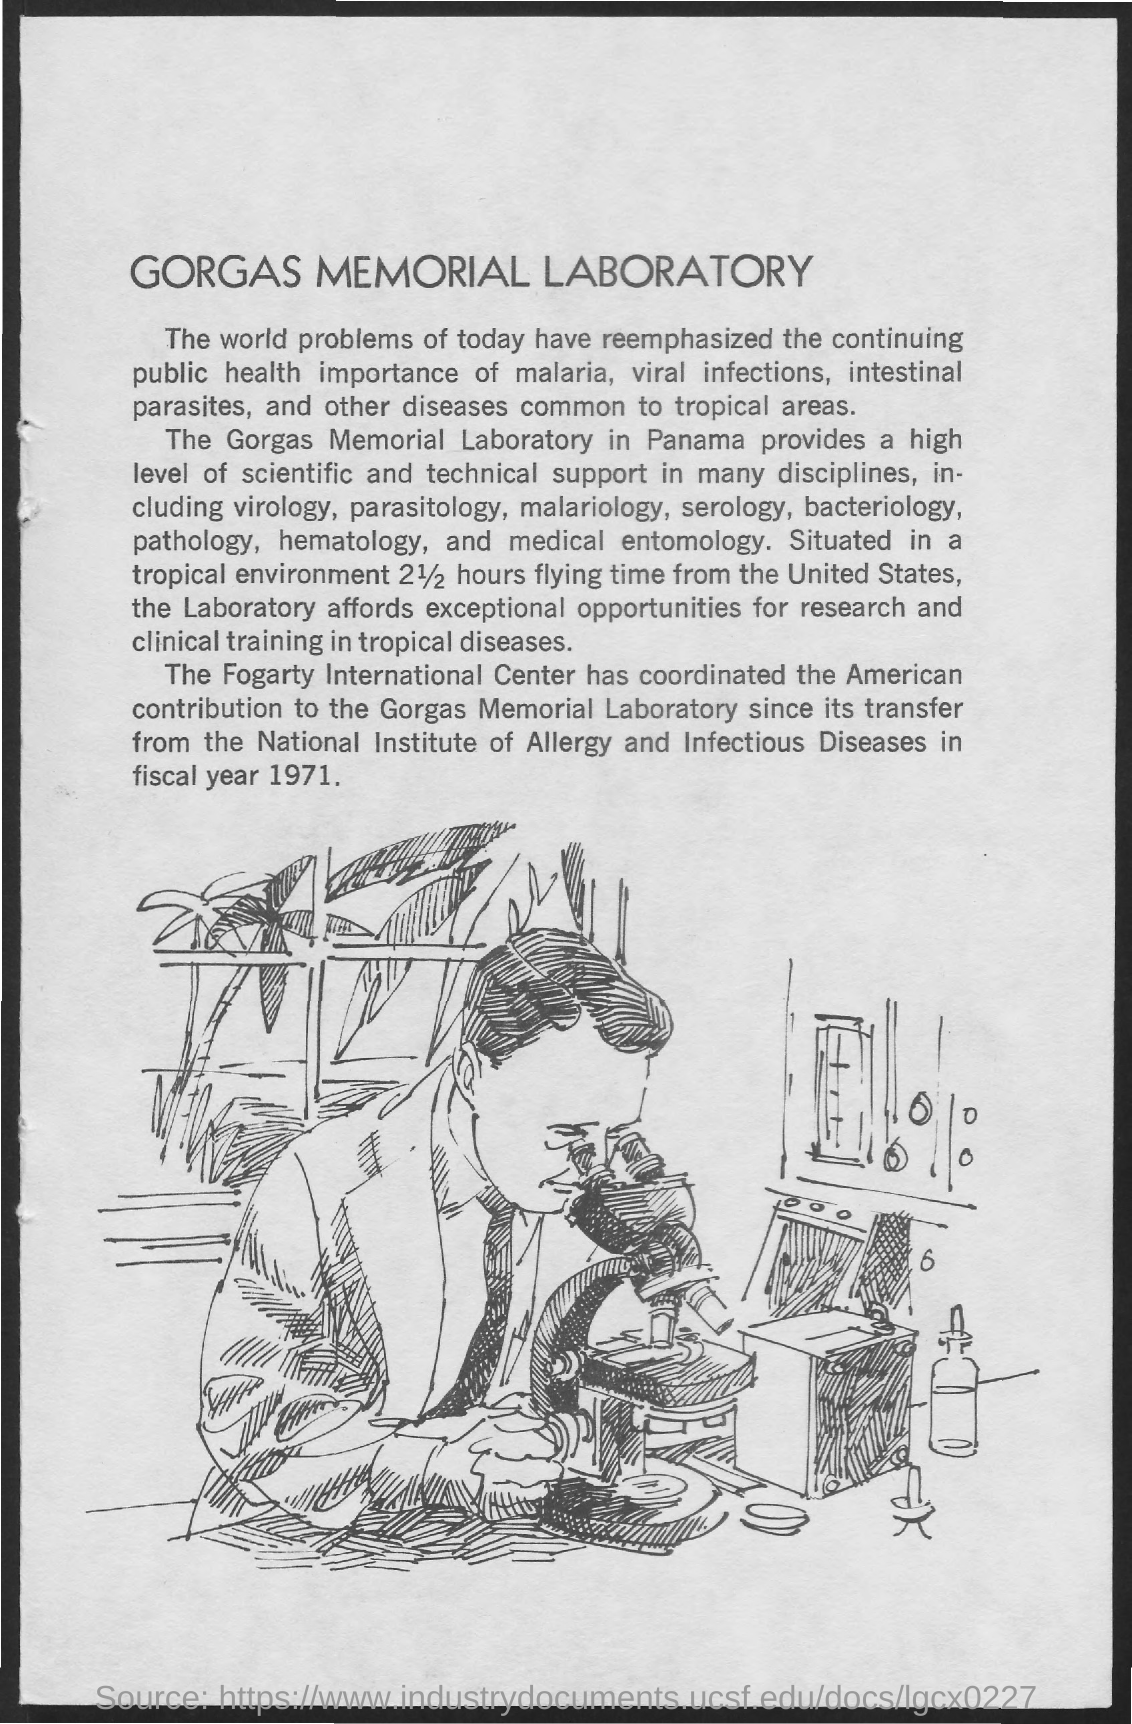Outline some significant characteristics in this image. The location of the lab is in Panama. In the fiscal year of 1971, the laboratory was transferred. The flying time from the United States to the laboratory is approximately 2 1/2 hours. Gorgas Memorial Laboratory is mentioned in the text. 